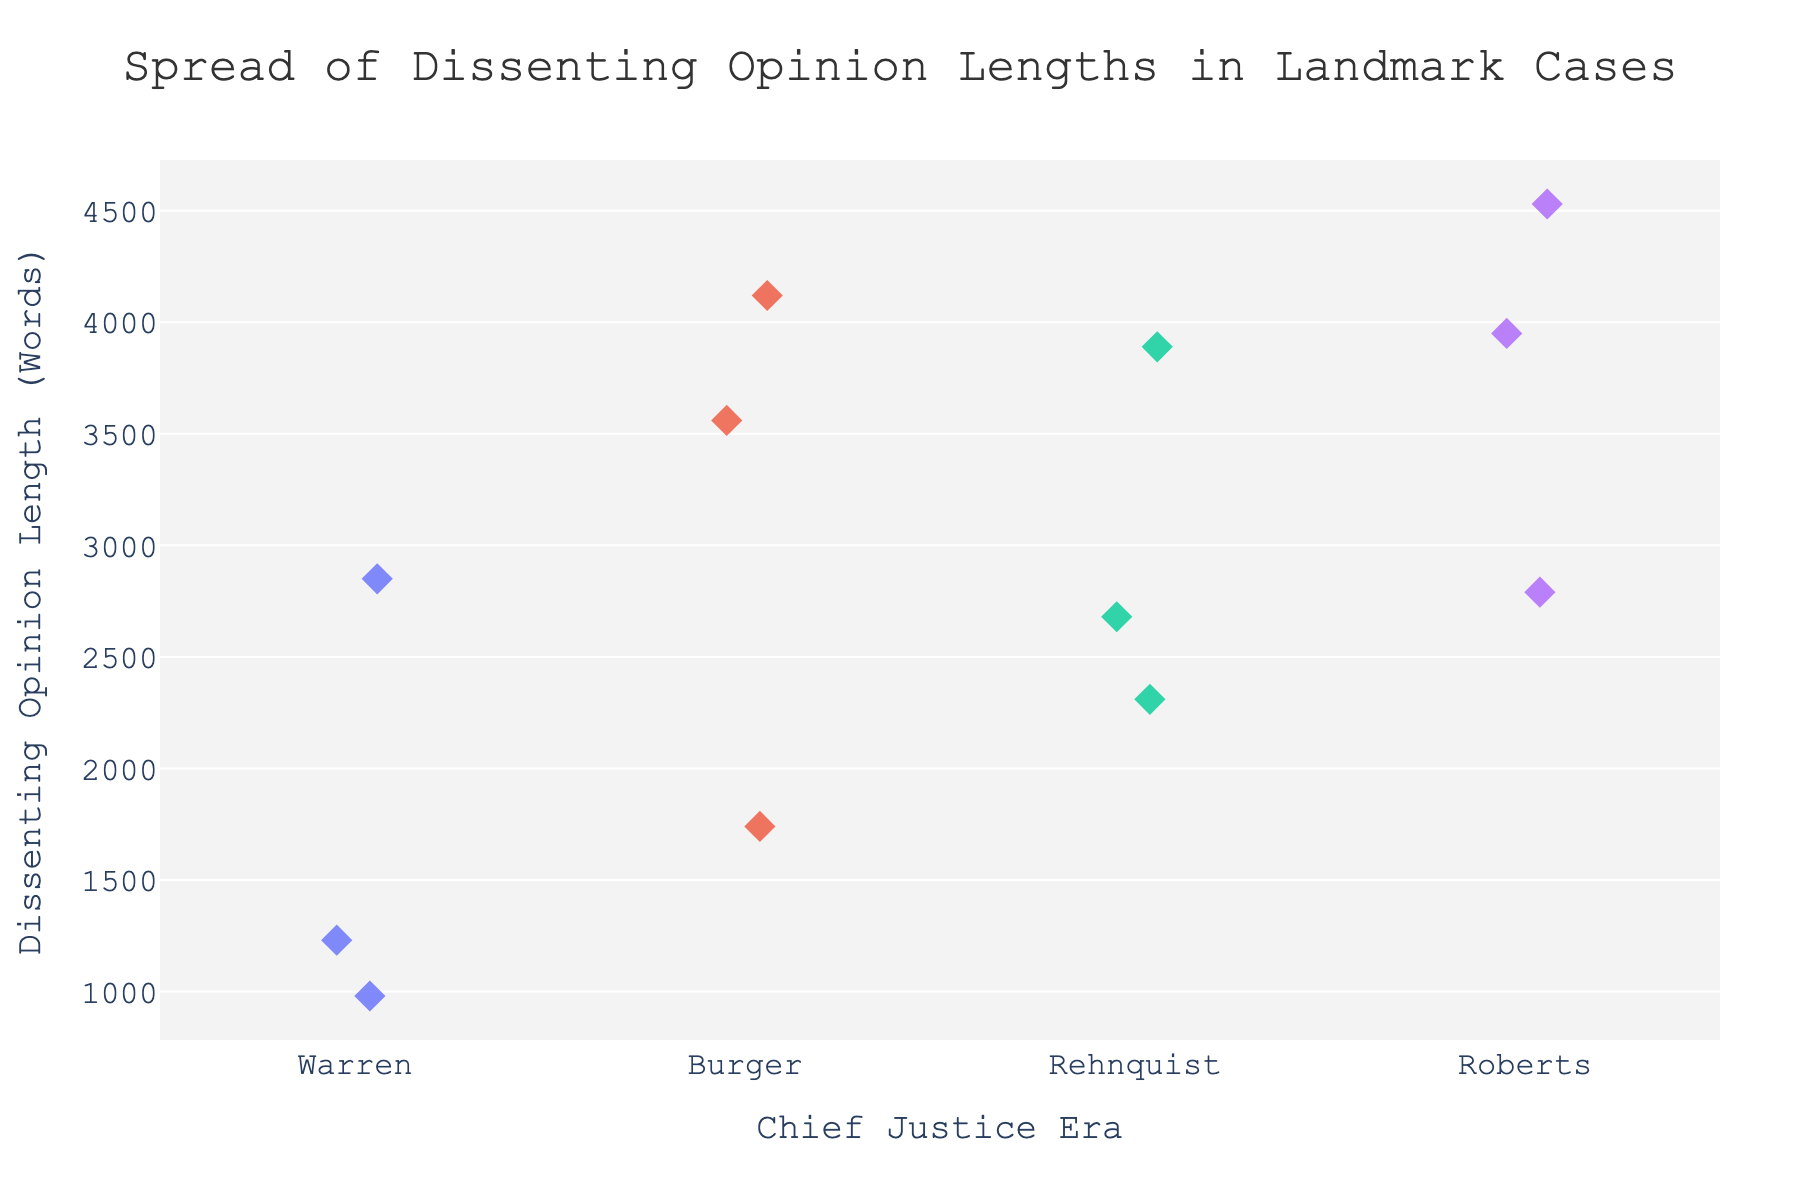What's the title of the figure? The title of the figure is located at the top of the plot and is displayed prominently to provide the viewer with an understanding of the data being presented.
Answer: "Spread of Dissenting Opinion Lengths in Landmark Cases" How many Chief Justice eras are represented in the plot? Each unique value along the x-axis represents a different Chief Justice era. Count the distinct labels to determine the number of eras.
Answer: 4 Which case under the Warren era had the longest dissenting opinion length? Hover over the data points in the Warren era. The case with the highest "Dissenting Opinion Length (Words)" value in the hover data is the answer.
Answer: Miranda v. Arizona Which Chief Justice era has the overall longest dissenting opinion length? Look for the highest point on the y-axis and identify the corresponding Chief Justice era from the hover data.
Answer: Roberts What is the range of dissenting opinion lengths (from shortest to longest) in the Burger era? Identify all the data points in the Burger era, then find the minimum and maximum values of "Dissenting Opinion Length (Words)" among these points.
Answer: 1740 to 4120 words Which landmark case in the Rehnquist era has a dissenting opinion length closest to 2500 words? Refer to the data points in the Rehnquist era and find the case with a "Dissenting Opinion Length (Words)" that is nearest to 2500 by comparing each value.
Answer: Grutter v. Bollinger How does the distribution of dissenting opinion lengths compare between the Warren and the Roberts eras? Examine the spread and clustering of data points for both the Warren and Roberts eras along the y-axis to observe how their distributions differ.
Answer: Roberts era has longer dissenting opinions and more variability compared to the Warren era Which case under the Roberts era had the longest dissenting opinion length? Hover over each data point in the Roberts era and identify the one with the highest "Dissenting Opinion Length (Words)" value.
Answer: National Federation of Independent Business v. Sebelius What's the median dissenting opinion length in the Rehnquist era? List out all dissenting opinion lengths in the Rehnquist era and find the median value by sorting the values and picking the middle one.
Answer: 2680 words 